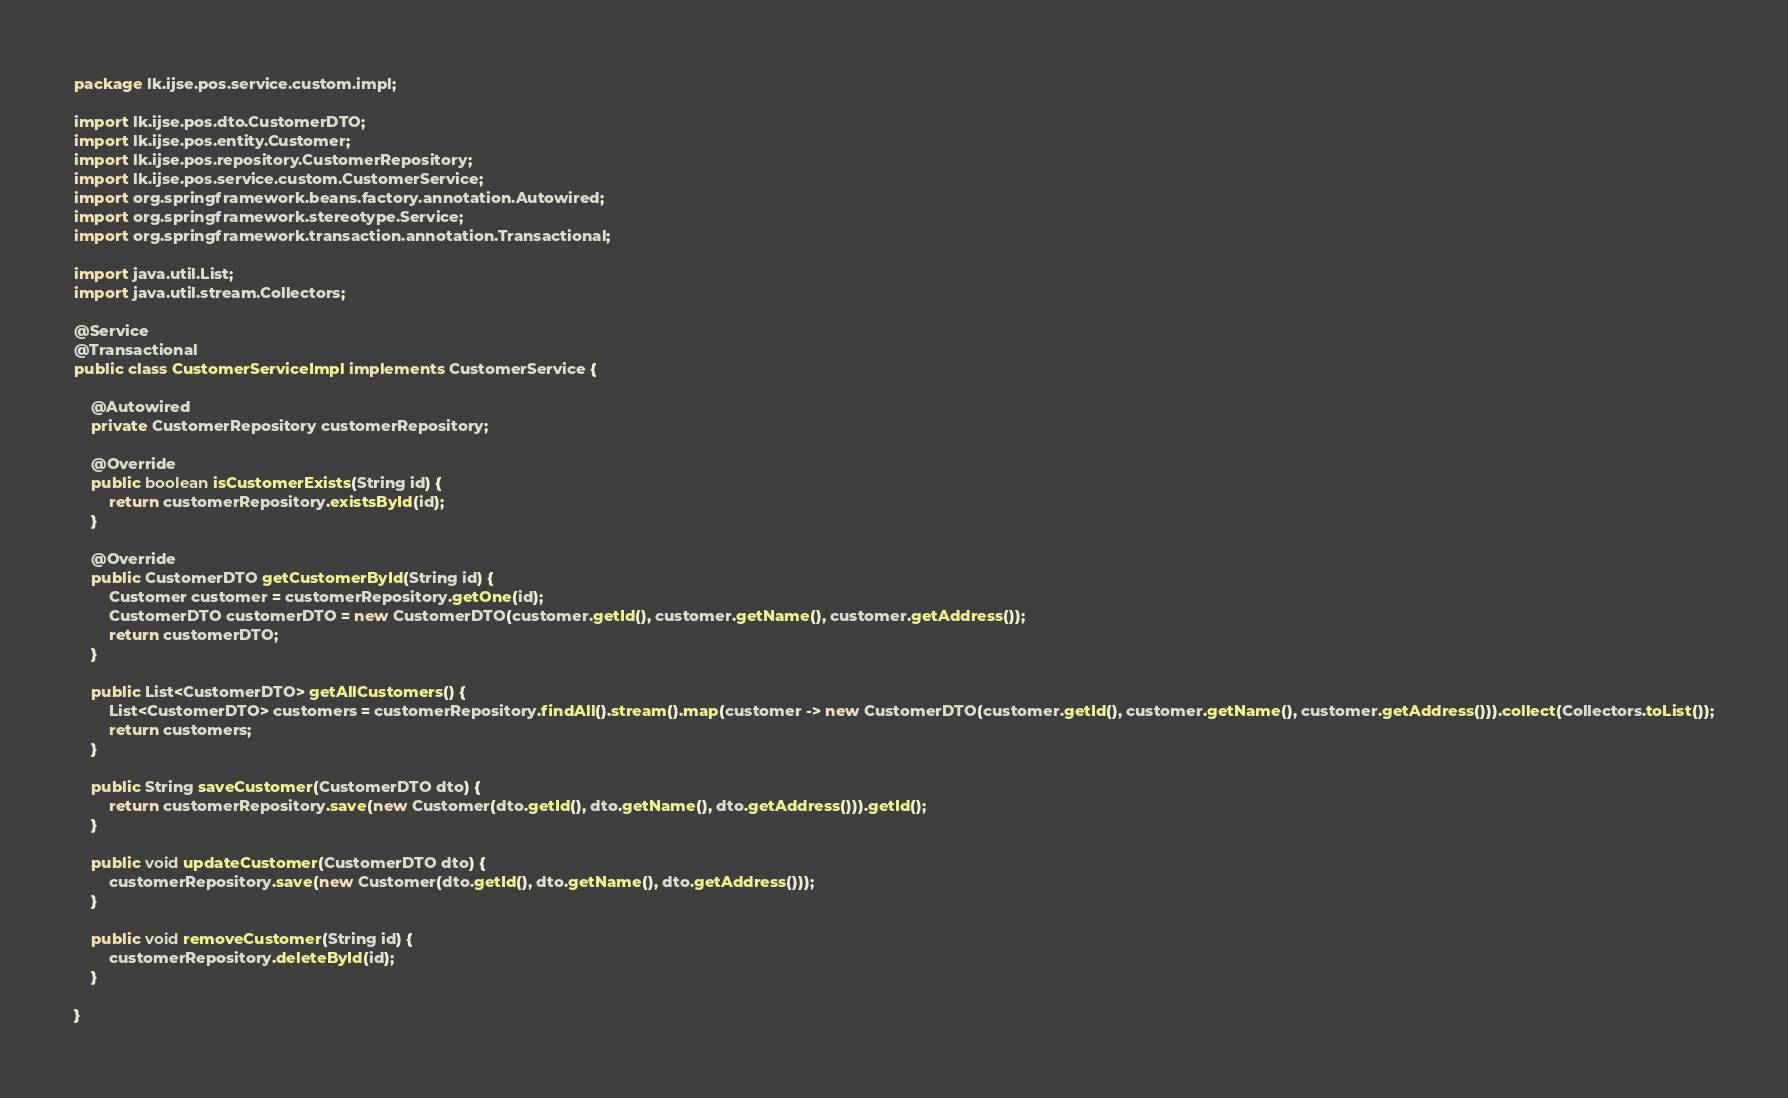Convert code to text. <code><loc_0><loc_0><loc_500><loc_500><_Java_>package lk.ijse.pos.service.custom.impl;

import lk.ijse.pos.dto.CustomerDTO;
import lk.ijse.pos.entity.Customer;
import lk.ijse.pos.repository.CustomerRepository;
import lk.ijse.pos.service.custom.CustomerService;
import org.springframework.beans.factory.annotation.Autowired;
import org.springframework.stereotype.Service;
import org.springframework.transaction.annotation.Transactional;

import java.util.List;
import java.util.stream.Collectors;

@Service
@Transactional
public class CustomerServiceImpl implements CustomerService {

    @Autowired
    private CustomerRepository customerRepository;

    @Override
    public boolean isCustomerExists(String id) {
        return customerRepository.existsById(id);
    }

    @Override
    public CustomerDTO getCustomerById(String id) {
        Customer customer = customerRepository.getOne(id);
        CustomerDTO customerDTO = new CustomerDTO(customer.getId(), customer.getName(), customer.getAddress());
        return customerDTO;
    }

    public List<CustomerDTO> getAllCustomers() {
        List<CustomerDTO> customers = customerRepository.findAll().stream().map(customer -> new CustomerDTO(customer.getId(), customer.getName(), customer.getAddress())).collect(Collectors.toList());
        return customers;
    }

    public String saveCustomer(CustomerDTO dto) {
        return customerRepository.save(new Customer(dto.getId(), dto.getName(), dto.getAddress())).getId();
    }

    public void updateCustomer(CustomerDTO dto) {
        customerRepository.save(new Customer(dto.getId(), dto.getName(), dto.getAddress()));
    }

    public void removeCustomer(String id) {
        customerRepository.deleteById(id);
    }

}
</code> 